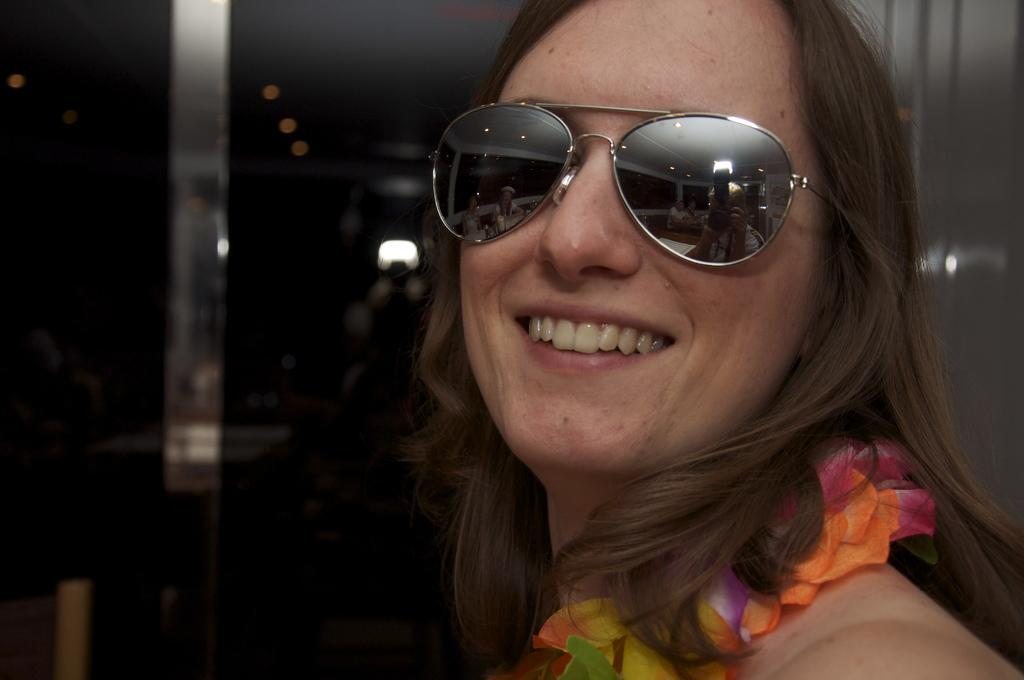Who is present in the image? There is a woman in the image. What is the woman wearing? The woman is wearing clothes and goggles. What is the woman's facial expression? The woman is smiling. What can be seen in the image besides the woman? There is a light in the image. How would you describe the background of the image? The background of the image is blurred. What type of map can be seen in the woman's hand in the image? There is no map present in the image; the woman is wearing goggles and not holding anything in her hand. 